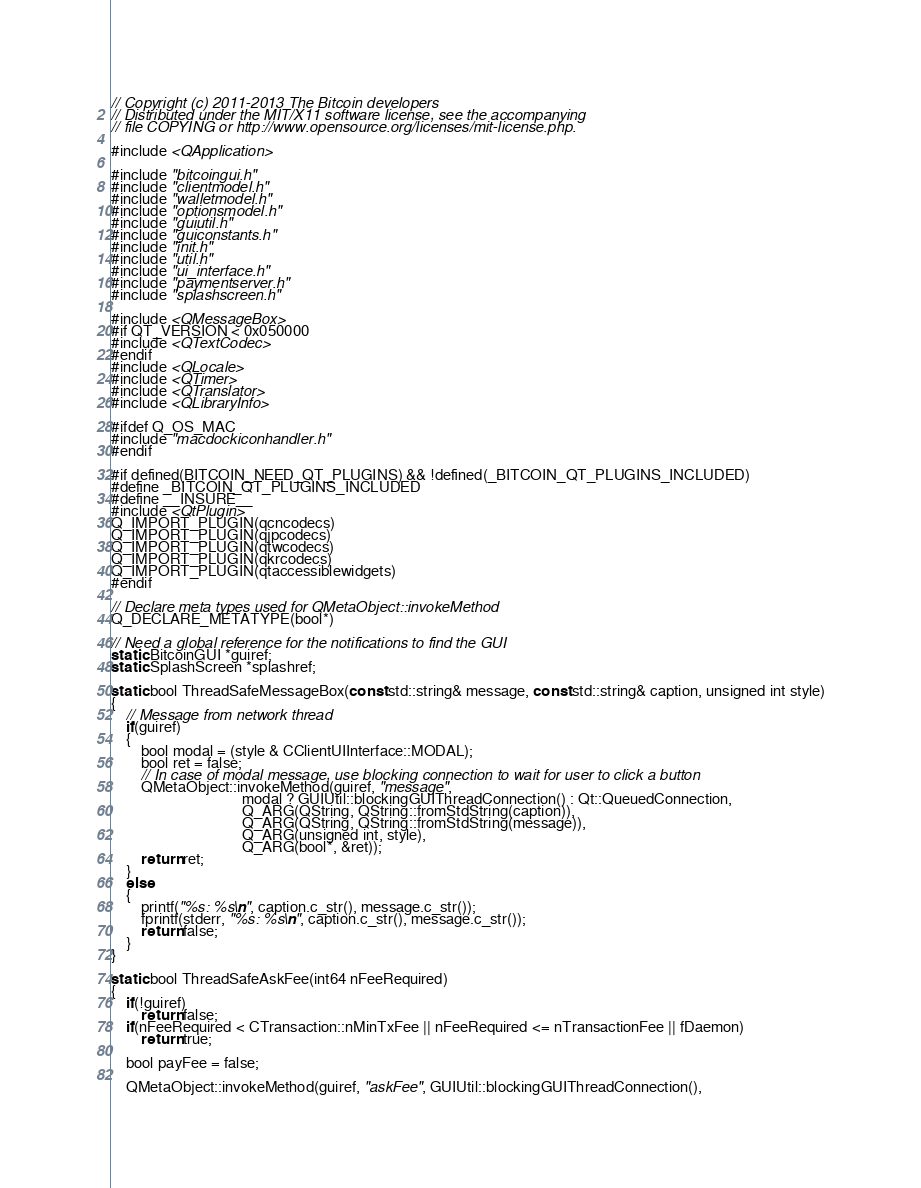Convert code to text. <code><loc_0><loc_0><loc_500><loc_500><_C++_>// Copyright (c) 2011-2013 The Bitcoin developers
// Distributed under the MIT/X11 software license, see the accompanying
// file COPYING or http://www.opensource.org/licenses/mit-license.php.

#include <QApplication>

#include "bitcoingui.h"
#include "clientmodel.h"
#include "walletmodel.h"
#include "optionsmodel.h"
#include "guiutil.h"
#include "guiconstants.h"
#include "init.h"
#include "util.h"
#include "ui_interface.h"
#include "paymentserver.h"
#include "splashscreen.h"

#include <QMessageBox>
#if QT_VERSION < 0x050000
#include <QTextCodec>
#endif
#include <QLocale>
#include <QTimer>
#include <QTranslator>
#include <QLibraryInfo>

#ifdef Q_OS_MAC
#include "macdockiconhandler.h"
#endif

#if defined(BITCOIN_NEED_QT_PLUGINS) && !defined(_BITCOIN_QT_PLUGINS_INCLUDED)
#define _BITCOIN_QT_PLUGINS_INCLUDED
#define __INSURE__
#include <QtPlugin>
Q_IMPORT_PLUGIN(qcncodecs)
Q_IMPORT_PLUGIN(qjpcodecs)
Q_IMPORT_PLUGIN(qtwcodecs)
Q_IMPORT_PLUGIN(qkrcodecs)
Q_IMPORT_PLUGIN(qtaccessiblewidgets)
#endif

// Declare meta types used for QMetaObject::invokeMethod
Q_DECLARE_METATYPE(bool*)

// Need a global reference for the notifications to find the GUI
static BitcoinGUI *guiref;
static SplashScreen *splashref;

static bool ThreadSafeMessageBox(const std::string& message, const std::string& caption, unsigned int style)
{
    // Message from network thread
    if(guiref)
    {
        bool modal = (style & CClientUIInterface::MODAL);
        bool ret = false;
        // In case of modal message, use blocking connection to wait for user to click a button
        QMetaObject::invokeMethod(guiref, "message",
                                   modal ? GUIUtil::blockingGUIThreadConnection() : Qt::QueuedConnection,
                                   Q_ARG(QString, QString::fromStdString(caption)),
                                   Q_ARG(QString, QString::fromStdString(message)),
                                   Q_ARG(unsigned int, style),
                                   Q_ARG(bool*, &ret));
        return ret;
    }
    else
    {
        printf("%s: %s\n", caption.c_str(), message.c_str());
        fprintf(stderr, "%s: %s\n", caption.c_str(), message.c_str());
        return false;
    }
}

static bool ThreadSafeAskFee(int64 nFeeRequired)
{
    if(!guiref)
        return false;
    if(nFeeRequired < CTransaction::nMinTxFee || nFeeRequired <= nTransactionFee || fDaemon)
        return true;

    bool payFee = false;

    QMetaObject::invokeMethod(guiref, "askFee", GUIUtil::blockingGUIThreadConnection(),</code> 